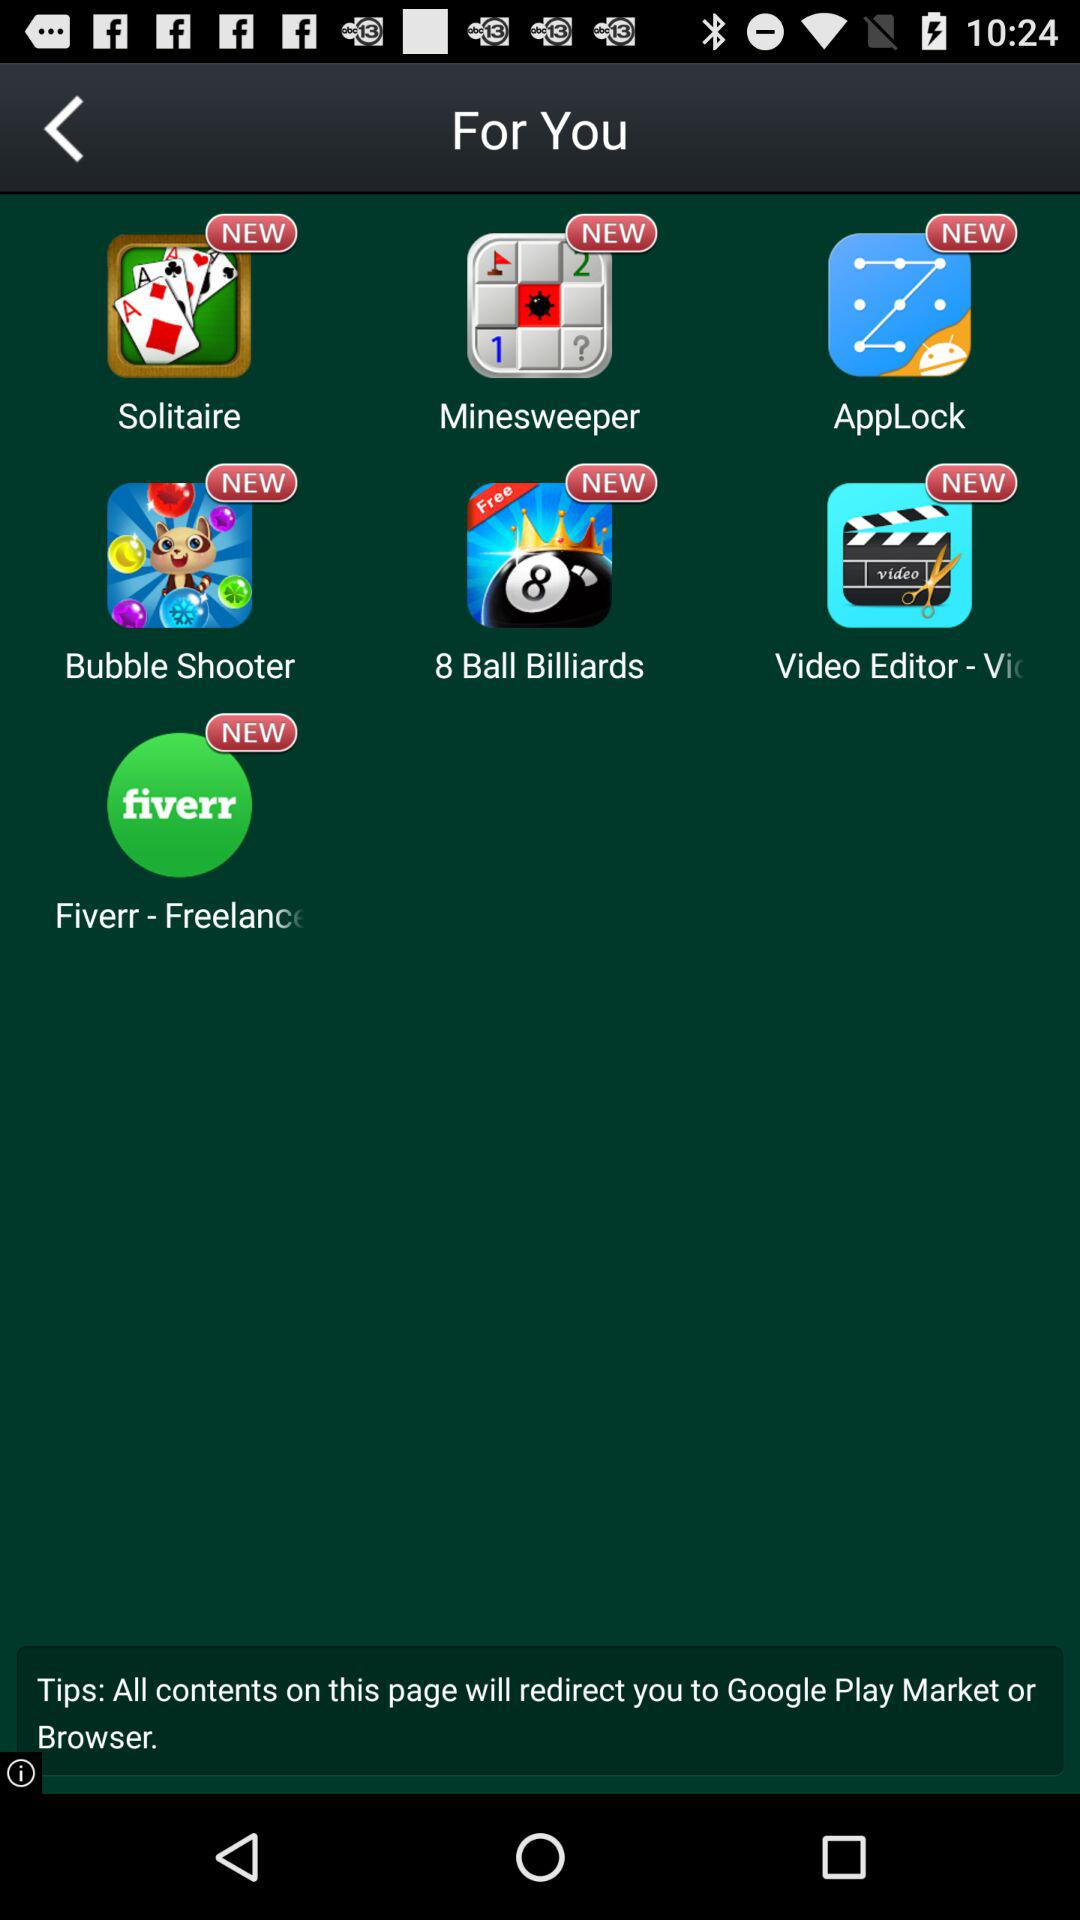Which game is recommended first?
Answer the question using a single word or phrase. Solitaire 